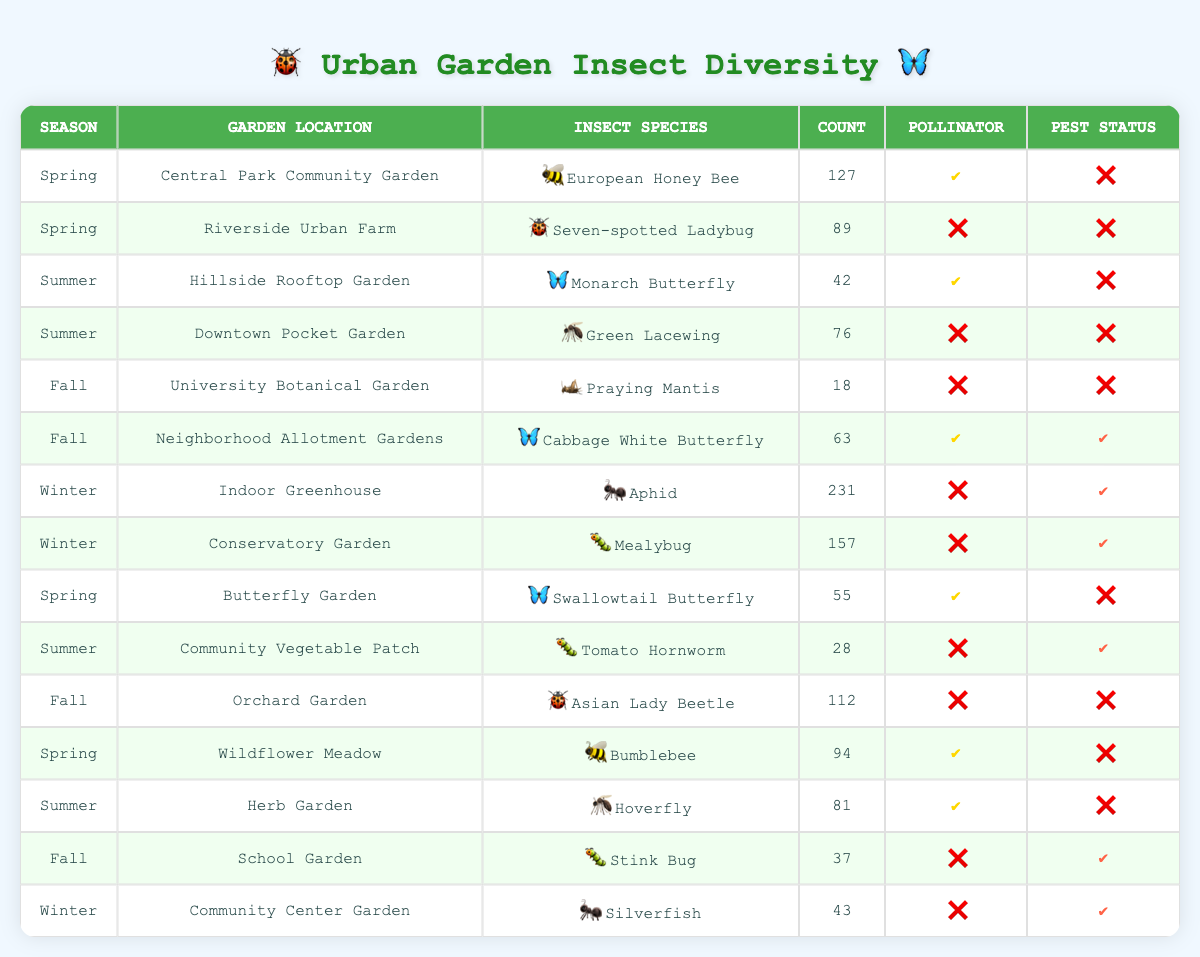What is the total count of insect species recorded during Spring? To find the total count of insect species in Spring, I must look at all rows with "Spring" in the season column and sum their counts: 127 (European Honey Bee) + 89 (Seven-spotted Ladybug) + 55 (Swallowtail Butterfly) + 94 (Bumblebee) = 365.
Answer: 365 How many insect species listed are considered pollinators? To determine how many species are pollinators, I will filter the rows where the "Pollinator" column is marked with a check (✔️). The pollinators are: European Honey Bee, Monarch Butterfly, Swallowtail Butterfly, Bumblebee, and Hoverfly, totaling 5 species.
Answer: 5 Are there any insects recorded as pests in the Winter season? In Winter, I will check the "Pest Status" column for any checks (✔️) while observing the corresponding season data. The insects are Aphid and Mealybug, both marked as pests (✔️), so the answer is yes.
Answer: Yes What is the average count of insects across all urban gardens in Summer? To calculate the average number of insects in Summer, first, I need to sum the counts of the summer species: 42 (Monarch Butterfly) + 76 (Green Lacewing) + 28 (Tomato Hornworm) + 81 (Hoverfly) = 227. There are 4 species, so the average is 227/4 = 56.75.
Answer: 56.75 Which garden location had the highest count of insects in Fall? First, I need to identify the counts of insect species recorded in Fall: 18 (University Botanical Garden) + 63 (Neighborhood Allotment Gardens) + 112 (Orchard Garden) + 37 (School Garden). The maximum is 112, from Orchard Garden.
Answer: Orchard Garden How many insect species are recorded as pollinators but also have pest status? By checking the rows for species marked as pollinators (✔️) and also having pest status (✔️), I find that the only species is the Cabbage White Butterfly from the Fall season, thus the count is 1.
Answer: 1 What is the total count of all insects recorded in the Indoor Greenhouse? The Indoor Greenhouse has one insect species, the Aphid, with a count of 231. Thus, the total is simply 231.
Answer: 231 Is the Green Lacewing a pollinator? Checking the "Pollinator" column for Green Lacewing shows it is marked with a cross (❌), indicating it is not a pollinator.
Answer: No Which insect species had the lowest count across all seasons? Looking across all the counts, the Praying Mantis in the Fall season had the lowest count of 18. Thus, the answer is Praying Mantis.
Answer: Praying Mantis 